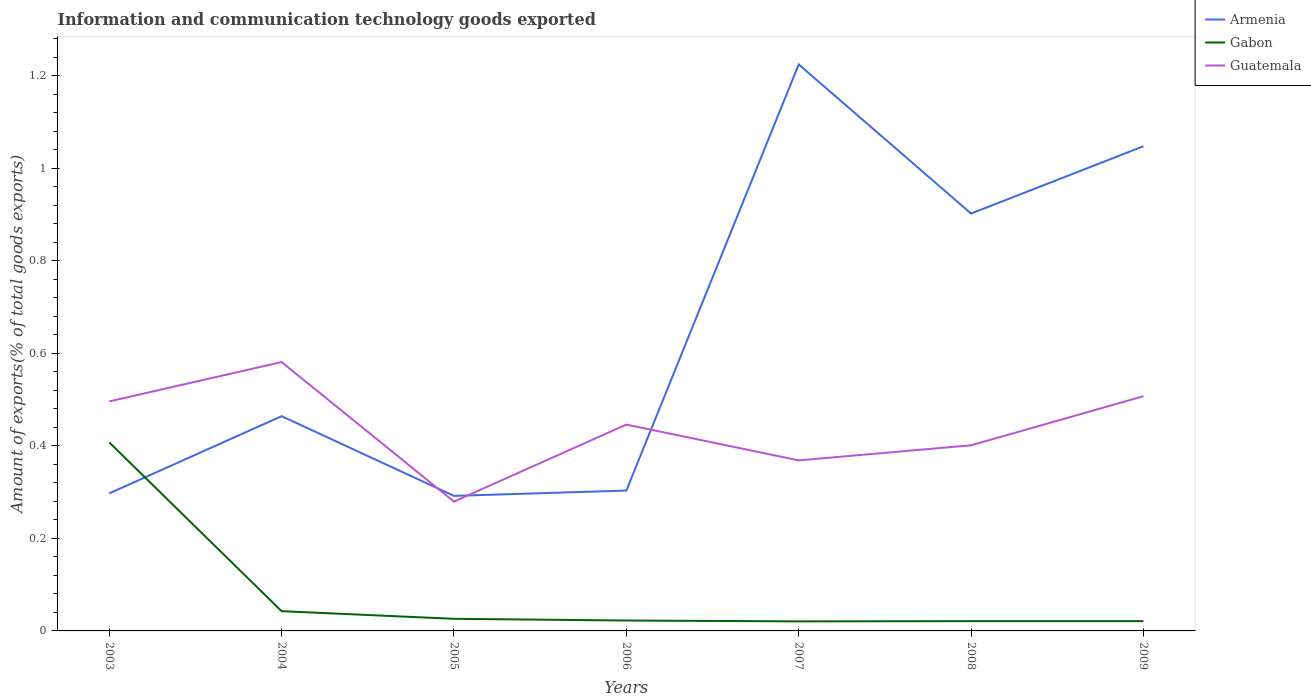How many different coloured lines are there?
Keep it short and to the point. 3. Across all years, what is the maximum amount of goods exported in Armenia?
Provide a succinct answer. 0.29. In which year was the amount of goods exported in Guatemala maximum?
Offer a terse response. 2005. What is the total amount of goods exported in Armenia in the graph?
Keep it short and to the point. -0.92. What is the difference between the highest and the second highest amount of goods exported in Armenia?
Make the answer very short. 0.93. What is the difference between two consecutive major ticks on the Y-axis?
Your response must be concise. 0.2. Are the values on the major ticks of Y-axis written in scientific E-notation?
Give a very brief answer. No. How are the legend labels stacked?
Your answer should be very brief. Vertical. What is the title of the graph?
Provide a succinct answer. Information and communication technology goods exported. Does "Lao PDR" appear as one of the legend labels in the graph?
Your answer should be compact. No. What is the label or title of the X-axis?
Your answer should be compact. Years. What is the label or title of the Y-axis?
Provide a short and direct response. Amount of exports(% of total goods exports). What is the Amount of exports(% of total goods exports) in Armenia in 2003?
Provide a succinct answer. 0.3. What is the Amount of exports(% of total goods exports) in Gabon in 2003?
Provide a short and direct response. 0.41. What is the Amount of exports(% of total goods exports) of Guatemala in 2003?
Make the answer very short. 0.5. What is the Amount of exports(% of total goods exports) of Armenia in 2004?
Make the answer very short. 0.46. What is the Amount of exports(% of total goods exports) of Gabon in 2004?
Keep it short and to the point. 0.04. What is the Amount of exports(% of total goods exports) of Guatemala in 2004?
Offer a very short reply. 0.58. What is the Amount of exports(% of total goods exports) of Armenia in 2005?
Provide a succinct answer. 0.29. What is the Amount of exports(% of total goods exports) of Gabon in 2005?
Ensure brevity in your answer.  0.03. What is the Amount of exports(% of total goods exports) of Guatemala in 2005?
Your answer should be very brief. 0.28. What is the Amount of exports(% of total goods exports) of Armenia in 2006?
Ensure brevity in your answer.  0.3. What is the Amount of exports(% of total goods exports) of Gabon in 2006?
Your answer should be compact. 0.02. What is the Amount of exports(% of total goods exports) of Guatemala in 2006?
Your answer should be compact. 0.45. What is the Amount of exports(% of total goods exports) in Armenia in 2007?
Keep it short and to the point. 1.22. What is the Amount of exports(% of total goods exports) of Gabon in 2007?
Your answer should be very brief. 0.02. What is the Amount of exports(% of total goods exports) in Guatemala in 2007?
Your answer should be compact. 0.37. What is the Amount of exports(% of total goods exports) in Armenia in 2008?
Provide a succinct answer. 0.9. What is the Amount of exports(% of total goods exports) in Gabon in 2008?
Provide a succinct answer. 0.02. What is the Amount of exports(% of total goods exports) of Guatemala in 2008?
Your answer should be very brief. 0.4. What is the Amount of exports(% of total goods exports) of Armenia in 2009?
Make the answer very short. 1.05. What is the Amount of exports(% of total goods exports) in Gabon in 2009?
Offer a terse response. 0.02. What is the Amount of exports(% of total goods exports) in Guatemala in 2009?
Make the answer very short. 0.51. Across all years, what is the maximum Amount of exports(% of total goods exports) in Armenia?
Offer a very short reply. 1.22. Across all years, what is the maximum Amount of exports(% of total goods exports) in Gabon?
Provide a succinct answer. 0.41. Across all years, what is the maximum Amount of exports(% of total goods exports) in Guatemala?
Provide a succinct answer. 0.58. Across all years, what is the minimum Amount of exports(% of total goods exports) of Armenia?
Offer a terse response. 0.29. Across all years, what is the minimum Amount of exports(% of total goods exports) of Gabon?
Your answer should be very brief. 0.02. Across all years, what is the minimum Amount of exports(% of total goods exports) in Guatemala?
Provide a short and direct response. 0.28. What is the total Amount of exports(% of total goods exports) of Armenia in the graph?
Provide a short and direct response. 4.53. What is the total Amount of exports(% of total goods exports) of Gabon in the graph?
Your response must be concise. 0.56. What is the total Amount of exports(% of total goods exports) of Guatemala in the graph?
Ensure brevity in your answer.  3.08. What is the difference between the Amount of exports(% of total goods exports) in Armenia in 2003 and that in 2004?
Offer a very short reply. -0.17. What is the difference between the Amount of exports(% of total goods exports) of Gabon in 2003 and that in 2004?
Your answer should be very brief. 0.36. What is the difference between the Amount of exports(% of total goods exports) of Guatemala in 2003 and that in 2004?
Make the answer very short. -0.08. What is the difference between the Amount of exports(% of total goods exports) of Armenia in 2003 and that in 2005?
Offer a very short reply. 0.01. What is the difference between the Amount of exports(% of total goods exports) in Gabon in 2003 and that in 2005?
Offer a terse response. 0.38. What is the difference between the Amount of exports(% of total goods exports) in Guatemala in 2003 and that in 2005?
Your response must be concise. 0.22. What is the difference between the Amount of exports(% of total goods exports) of Armenia in 2003 and that in 2006?
Your answer should be compact. -0.01. What is the difference between the Amount of exports(% of total goods exports) in Gabon in 2003 and that in 2006?
Offer a terse response. 0.38. What is the difference between the Amount of exports(% of total goods exports) in Guatemala in 2003 and that in 2006?
Provide a succinct answer. 0.05. What is the difference between the Amount of exports(% of total goods exports) in Armenia in 2003 and that in 2007?
Provide a short and direct response. -0.93. What is the difference between the Amount of exports(% of total goods exports) of Gabon in 2003 and that in 2007?
Provide a short and direct response. 0.39. What is the difference between the Amount of exports(% of total goods exports) of Guatemala in 2003 and that in 2007?
Make the answer very short. 0.13. What is the difference between the Amount of exports(% of total goods exports) of Armenia in 2003 and that in 2008?
Give a very brief answer. -0.6. What is the difference between the Amount of exports(% of total goods exports) of Gabon in 2003 and that in 2008?
Offer a terse response. 0.39. What is the difference between the Amount of exports(% of total goods exports) of Guatemala in 2003 and that in 2008?
Your response must be concise. 0.09. What is the difference between the Amount of exports(% of total goods exports) of Armenia in 2003 and that in 2009?
Offer a very short reply. -0.75. What is the difference between the Amount of exports(% of total goods exports) in Gabon in 2003 and that in 2009?
Your answer should be very brief. 0.39. What is the difference between the Amount of exports(% of total goods exports) of Guatemala in 2003 and that in 2009?
Your answer should be compact. -0.01. What is the difference between the Amount of exports(% of total goods exports) in Armenia in 2004 and that in 2005?
Your response must be concise. 0.17. What is the difference between the Amount of exports(% of total goods exports) in Gabon in 2004 and that in 2005?
Your answer should be very brief. 0.02. What is the difference between the Amount of exports(% of total goods exports) of Guatemala in 2004 and that in 2005?
Ensure brevity in your answer.  0.3. What is the difference between the Amount of exports(% of total goods exports) in Armenia in 2004 and that in 2006?
Your answer should be very brief. 0.16. What is the difference between the Amount of exports(% of total goods exports) in Gabon in 2004 and that in 2006?
Ensure brevity in your answer.  0.02. What is the difference between the Amount of exports(% of total goods exports) of Guatemala in 2004 and that in 2006?
Offer a very short reply. 0.14. What is the difference between the Amount of exports(% of total goods exports) of Armenia in 2004 and that in 2007?
Make the answer very short. -0.76. What is the difference between the Amount of exports(% of total goods exports) of Gabon in 2004 and that in 2007?
Provide a succinct answer. 0.02. What is the difference between the Amount of exports(% of total goods exports) of Guatemala in 2004 and that in 2007?
Provide a short and direct response. 0.21. What is the difference between the Amount of exports(% of total goods exports) of Armenia in 2004 and that in 2008?
Provide a short and direct response. -0.44. What is the difference between the Amount of exports(% of total goods exports) of Gabon in 2004 and that in 2008?
Keep it short and to the point. 0.02. What is the difference between the Amount of exports(% of total goods exports) in Guatemala in 2004 and that in 2008?
Make the answer very short. 0.18. What is the difference between the Amount of exports(% of total goods exports) in Armenia in 2004 and that in 2009?
Keep it short and to the point. -0.58. What is the difference between the Amount of exports(% of total goods exports) in Gabon in 2004 and that in 2009?
Keep it short and to the point. 0.02. What is the difference between the Amount of exports(% of total goods exports) of Guatemala in 2004 and that in 2009?
Provide a succinct answer. 0.07. What is the difference between the Amount of exports(% of total goods exports) in Armenia in 2005 and that in 2006?
Make the answer very short. -0.01. What is the difference between the Amount of exports(% of total goods exports) in Gabon in 2005 and that in 2006?
Provide a short and direct response. 0. What is the difference between the Amount of exports(% of total goods exports) of Guatemala in 2005 and that in 2006?
Ensure brevity in your answer.  -0.17. What is the difference between the Amount of exports(% of total goods exports) of Armenia in 2005 and that in 2007?
Your response must be concise. -0.93. What is the difference between the Amount of exports(% of total goods exports) of Gabon in 2005 and that in 2007?
Make the answer very short. 0.01. What is the difference between the Amount of exports(% of total goods exports) in Guatemala in 2005 and that in 2007?
Provide a short and direct response. -0.09. What is the difference between the Amount of exports(% of total goods exports) of Armenia in 2005 and that in 2008?
Provide a succinct answer. -0.61. What is the difference between the Amount of exports(% of total goods exports) of Gabon in 2005 and that in 2008?
Your answer should be very brief. 0.01. What is the difference between the Amount of exports(% of total goods exports) of Guatemala in 2005 and that in 2008?
Keep it short and to the point. -0.12. What is the difference between the Amount of exports(% of total goods exports) of Armenia in 2005 and that in 2009?
Offer a terse response. -0.76. What is the difference between the Amount of exports(% of total goods exports) of Gabon in 2005 and that in 2009?
Provide a succinct answer. 0.01. What is the difference between the Amount of exports(% of total goods exports) of Guatemala in 2005 and that in 2009?
Your answer should be compact. -0.23. What is the difference between the Amount of exports(% of total goods exports) of Armenia in 2006 and that in 2007?
Your answer should be very brief. -0.92. What is the difference between the Amount of exports(% of total goods exports) of Gabon in 2006 and that in 2007?
Make the answer very short. 0. What is the difference between the Amount of exports(% of total goods exports) in Guatemala in 2006 and that in 2007?
Provide a short and direct response. 0.08. What is the difference between the Amount of exports(% of total goods exports) of Armenia in 2006 and that in 2008?
Your response must be concise. -0.6. What is the difference between the Amount of exports(% of total goods exports) in Gabon in 2006 and that in 2008?
Provide a succinct answer. 0. What is the difference between the Amount of exports(% of total goods exports) of Guatemala in 2006 and that in 2008?
Your response must be concise. 0.04. What is the difference between the Amount of exports(% of total goods exports) in Armenia in 2006 and that in 2009?
Keep it short and to the point. -0.74. What is the difference between the Amount of exports(% of total goods exports) of Gabon in 2006 and that in 2009?
Ensure brevity in your answer.  0. What is the difference between the Amount of exports(% of total goods exports) of Guatemala in 2006 and that in 2009?
Give a very brief answer. -0.06. What is the difference between the Amount of exports(% of total goods exports) of Armenia in 2007 and that in 2008?
Your answer should be very brief. 0.32. What is the difference between the Amount of exports(% of total goods exports) of Gabon in 2007 and that in 2008?
Your response must be concise. -0. What is the difference between the Amount of exports(% of total goods exports) in Guatemala in 2007 and that in 2008?
Ensure brevity in your answer.  -0.03. What is the difference between the Amount of exports(% of total goods exports) in Armenia in 2007 and that in 2009?
Your answer should be very brief. 0.18. What is the difference between the Amount of exports(% of total goods exports) in Gabon in 2007 and that in 2009?
Provide a succinct answer. -0. What is the difference between the Amount of exports(% of total goods exports) of Guatemala in 2007 and that in 2009?
Your answer should be very brief. -0.14. What is the difference between the Amount of exports(% of total goods exports) in Armenia in 2008 and that in 2009?
Offer a terse response. -0.15. What is the difference between the Amount of exports(% of total goods exports) of Guatemala in 2008 and that in 2009?
Your answer should be compact. -0.11. What is the difference between the Amount of exports(% of total goods exports) of Armenia in 2003 and the Amount of exports(% of total goods exports) of Gabon in 2004?
Provide a succinct answer. 0.25. What is the difference between the Amount of exports(% of total goods exports) of Armenia in 2003 and the Amount of exports(% of total goods exports) of Guatemala in 2004?
Ensure brevity in your answer.  -0.28. What is the difference between the Amount of exports(% of total goods exports) of Gabon in 2003 and the Amount of exports(% of total goods exports) of Guatemala in 2004?
Offer a terse response. -0.17. What is the difference between the Amount of exports(% of total goods exports) in Armenia in 2003 and the Amount of exports(% of total goods exports) in Gabon in 2005?
Provide a succinct answer. 0.27. What is the difference between the Amount of exports(% of total goods exports) of Armenia in 2003 and the Amount of exports(% of total goods exports) of Guatemala in 2005?
Your answer should be very brief. 0.02. What is the difference between the Amount of exports(% of total goods exports) of Gabon in 2003 and the Amount of exports(% of total goods exports) of Guatemala in 2005?
Provide a short and direct response. 0.13. What is the difference between the Amount of exports(% of total goods exports) of Armenia in 2003 and the Amount of exports(% of total goods exports) of Gabon in 2006?
Your answer should be compact. 0.27. What is the difference between the Amount of exports(% of total goods exports) of Armenia in 2003 and the Amount of exports(% of total goods exports) of Guatemala in 2006?
Give a very brief answer. -0.15. What is the difference between the Amount of exports(% of total goods exports) in Gabon in 2003 and the Amount of exports(% of total goods exports) in Guatemala in 2006?
Provide a short and direct response. -0.04. What is the difference between the Amount of exports(% of total goods exports) of Armenia in 2003 and the Amount of exports(% of total goods exports) of Gabon in 2007?
Your answer should be compact. 0.28. What is the difference between the Amount of exports(% of total goods exports) in Armenia in 2003 and the Amount of exports(% of total goods exports) in Guatemala in 2007?
Offer a terse response. -0.07. What is the difference between the Amount of exports(% of total goods exports) of Gabon in 2003 and the Amount of exports(% of total goods exports) of Guatemala in 2007?
Offer a terse response. 0.04. What is the difference between the Amount of exports(% of total goods exports) of Armenia in 2003 and the Amount of exports(% of total goods exports) of Gabon in 2008?
Provide a short and direct response. 0.28. What is the difference between the Amount of exports(% of total goods exports) of Armenia in 2003 and the Amount of exports(% of total goods exports) of Guatemala in 2008?
Provide a succinct answer. -0.1. What is the difference between the Amount of exports(% of total goods exports) in Gabon in 2003 and the Amount of exports(% of total goods exports) in Guatemala in 2008?
Offer a terse response. 0.01. What is the difference between the Amount of exports(% of total goods exports) of Armenia in 2003 and the Amount of exports(% of total goods exports) of Gabon in 2009?
Your answer should be compact. 0.28. What is the difference between the Amount of exports(% of total goods exports) in Armenia in 2003 and the Amount of exports(% of total goods exports) in Guatemala in 2009?
Your answer should be very brief. -0.21. What is the difference between the Amount of exports(% of total goods exports) in Gabon in 2003 and the Amount of exports(% of total goods exports) in Guatemala in 2009?
Offer a very short reply. -0.1. What is the difference between the Amount of exports(% of total goods exports) in Armenia in 2004 and the Amount of exports(% of total goods exports) in Gabon in 2005?
Keep it short and to the point. 0.44. What is the difference between the Amount of exports(% of total goods exports) of Armenia in 2004 and the Amount of exports(% of total goods exports) of Guatemala in 2005?
Your response must be concise. 0.18. What is the difference between the Amount of exports(% of total goods exports) of Gabon in 2004 and the Amount of exports(% of total goods exports) of Guatemala in 2005?
Provide a succinct answer. -0.24. What is the difference between the Amount of exports(% of total goods exports) in Armenia in 2004 and the Amount of exports(% of total goods exports) in Gabon in 2006?
Keep it short and to the point. 0.44. What is the difference between the Amount of exports(% of total goods exports) in Armenia in 2004 and the Amount of exports(% of total goods exports) in Guatemala in 2006?
Ensure brevity in your answer.  0.02. What is the difference between the Amount of exports(% of total goods exports) of Gabon in 2004 and the Amount of exports(% of total goods exports) of Guatemala in 2006?
Ensure brevity in your answer.  -0.4. What is the difference between the Amount of exports(% of total goods exports) of Armenia in 2004 and the Amount of exports(% of total goods exports) of Gabon in 2007?
Your answer should be very brief. 0.44. What is the difference between the Amount of exports(% of total goods exports) of Armenia in 2004 and the Amount of exports(% of total goods exports) of Guatemala in 2007?
Offer a terse response. 0.1. What is the difference between the Amount of exports(% of total goods exports) in Gabon in 2004 and the Amount of exports(% of total goods exports) in Guatemala in 2007?
Offer a very short reply. -0.33. What is the difference between the Amount of exports(% of total goods exports) of Armenia in 2004 and the Amount of exports(% of total goods exports) of Gabon in 2008?
Keep it short and to the point. 0.44. What is the difference between the Amount of exports(% of total goods exports) in Armenia in 2004 and the Amount of exports(% of total goods exports) in Guatemala in 2008?
Your answer should be very brief. 0.06. What is the difference between the Amount of exports(% of total goods exports) in Gabon in 2004 and the Amount of exports(% of total goods exports) in Guatemala in 2008?
Provide a succinct answer. -0.36. What is the difference between the Amount of exports(% of total goods exports) in Armenia in 2004 and the Amount of exports(% of total goods exports) in Gabon in 2009?
Provide a succinct answer. 0.44. What is the difference between the Amount of exports(% of total goods exports) of Armenia in 2004 and the Amount of exports(% of total goods exports) of Guatemala in 2009?
Offer a terse response. -0.04. What is the difference between the Amount of exports(% of total goods exports) of Gabon in 2004 and the Amount of exports(% of total goods exports) of Guatemala in 2009?
Keep it short and to the point. -0.46. What is the difference between the Amount of exports(% of total goods exports) of Armenia in 2005 and the Amount of exports(% of total goods exports) of Gabon in 2006?
Offer a terse response. 0.27. What is the difference between the Amount of exports(% of total goods exports) in Armenia in 2005 and the Amount of exports(% of total goods exports) in Guatemala in 2006?
Provide a succinct answer. -0.15. What is the difference between the Amount of exports(% of total goods exports) of Gabon in 2005 and the Amount of exports(% of total goods exports) of Guatemala in 2006?
Keep it short and to the point. -0.42. What is the difference between the Amount of exports(% of total goods exports) of Armenia in 2005 and the Amount of exports(% of total goods exports) of Gabon in 2007?
Offer a very short reply. 0.27. What is the difference between the Amount of exports(% of total goods exports) of Armenia in 2005 and the Amount of exports(% of total goods exports) of Guatemala in 2007?
Offer a very short reply. -0.08. What is the difference between the Amount of exports(% of total goods exports) of Gabon in 2005 and the Amount of exports(% of total goods exports) of Guatemala in 2007?
Provide a succinct answer. -0.34. What is the difference between the Amount of exports(% of total goods exports) in Armenia in 2005 and the Amount of exports(% of total goods exports) in Gabon in 2008?
Offer a very short reply. 0.27. What is the difference between the Amount of exports(% of total goods exports) in Armenia in 2005 and the Amount of exports(% of total goods exports) in Guatemala in 2008?
Offer a terse response. -0.11. What is the difference between the Amount of exports(% of total goods exports) in Gabon in 2005 and the Amount of exports(% of total goods exports) in Guatemala in 2008?
Provide a succinct answer. -0.37. What is the difference between the Amount of exports(% of total goods exports) in Armenia in 2005 and the Amount of exports(% of total goods exports) in Gabon in 2009?
Provide a short and direct response. 0.27. What is the difference between the Amount of exports(% of total goods exports) of Armenia in 2005 and the Amount of exports(% of total goods exports) of Guatemala in 2009?
Offer a terse response. -0.22. What is the difference between the Amount of exports(% of total goods exports) of Gabon in 2005 and the Amount of exports(% of total goods exports) of Guatemala in 2009?
Your answer should be very brief. -0.48. What is the difference between the Amount of exports(% of total goods exports) of Armenia in 2006 and the Amount of exports(% of total goods exports) of Gabon in 2007?
Keep it short and to the point. 0.28. What is the difference between the Amount of exports(% of total goods exports) of Armenia in 2006 and the Amount of exports(% of total goods exports) of Guatemala in 2007?
Your response must be concise. -0.07. What is the difference between the Amount of exports(% of total goods exports) in Gabon in 2006 and the Amount of exports(% of total goods exports) in Guatemala in 2007?
Offer a very short reply. -0.35. What is the difference between the Amount of exports(% of total goods exports) of Armenia in 2006 and the Amount of exports(% of total goods exports) of Gabon in 2008?
Provide a succinct answer. 0.28. What is the difference between the Amount of exports(% of total goods exports) of Armenia in 2006 and the Amount of exports(% of total goods exports) of Guatemala in 2008?
Your answer should be very brief. -0.1. What is the difference between the Amount of exports(% of total goods exports) in Gabon in 2006 and the Amount of exports(% of total goods exports) in Guatemala in 2008?
Ensure brevity in your answer.  -0.38. What is the difference between the Amount of exports(% of total goods exports) of Armenia in 2006 and the Amount of exports(% of total goods exports) of Gabon in 2009?
Make the answer very short. 0.28. What is the difference between the Amount of exports(% of total goods exports) in Armenia in 2006 and the Amount of exports(% of total goods exports) in Guatemala in 2009?
Provide a short and direct response. -0.2. What is the difference between the Amount of exports(% of total goods exports) of Gabon in 2006 and the Amount of exports(% of total goods exports) of Guatemala in 2009?
Give a very brief answer. -0.48. What is the difference between the Amount of exports(% of total goods exports) of Armenia in 2007 and the Amount of exports(% of total goods exports) of Gabon in 2008?
Your answer should be very brief. 1.2. What is the difference between the Amount of exports(% of total goods exports) of Armenia in 2007 and the Amount of exports(% of total goods exports) of Guatemala in 2008?
Provide a short and direct response. 0.82. What is the difference between the Amount of exports(% of total goods exports) in Gabon in 2007 and the Amount of exports(% of total goods exports) in Guatemala in 2008?
Make the answer very short. -0.38. What is the difference between the Amount of exports(% of total goods exports) of Armenia in 2007 and the Amount of exports(% of total goods exports) of Gabon in 2009?
Offer a terse response. 1.2. What is the difference between the Amount of exports(% of total goods exports) of Armenia in 2007 and the Amount of exports(% of total goods exports) of Guatemala in 2009?
Your response must be concise. 0.72. What is the difference between the Amount of exports(% of total goods exports) of Gabon in 2007 and the Amount of exports(% of total goods exports) of Guatemala in 2009?
Make the answer very short. -0.49. What is the difference between the Amount of exports(% of total goods exports) of Armenia in 2008 and the Amount of exports(% of total goods exports) of Gabon in 2009?
Give a very brief answer. 0.88. What is the difference between the Amount of exports(% of total goods exports) in Armenia in 2008 and the Amount of exports(% of total goods exports) in Guatemala in 2009?
Provide a succinct answer. 0.39. What is the difference between the Amount of exports(% of total goods exports) of Gabon in 2008 and the Amount of exports(% of total goods exports) of Guatemala in 2009?
Make the answer very short. -0.49. What is the average Amount of exports(% of total goods exports) in Armenia per year?
Make the answer very short. 0.65. What is the average Amount of exports(% of total goods exports) of Gabon per year?
Keep it short and to the point. 0.08. What is the average Amount of exports(% of total goods exports) in Guatemala per year?
Make the answer very short. 0.44. In the year 2003, what is the difference between the Amount of exports(% of total goods exports) in Armenia and Amount of exports(% of total goods exports) in Gabon?
Ensure brevity in your answer.  -0.11. In the year 2003, what is the difference between the Amount of exports(% of total goods exports) of Armenia and Amount of exports(% of total goods exports) of Guatemala?
Provide a short and direct response. -0.2. In the year 2003, what is the difference between the Amount of exports(% of total goods exports) in Gabon and Amount of exports(% of total goods exports) in Guatemala?
Your response must be concise. -0.09. In the year 2004, what is the difference between the Amount of exports(% of total goods exports) of Armenia and Amount of exports(% of total goods exports) of Gabon?
Keep it short and to the point. 0.42. In the year 2004, what is the difference between the Amount of exports(% of total goods exports) of Armenia and Amount of exports(% of total goods exports) of Guatemala?
Ensure brevity in your answer.  -0.12. In the year 2004, what is the difference between the Amount of exports(% of total goods exports) of Gabon and Amount of exports(% of total goods exports) of Guatemala?
Your response must be concise. -0.54. In the year 2005, what is the difference between the Amount of exports(% of total goods exports) in Armenia and Amount of exports(% of total goods exports) in Gabon?
Offer a terse response. 0.27. In the year 2005, what is the difference between the Amount of exports(% of total goods exports) in Armenia and Amount of exports(% of total goods exports) in Guatemala?
Your response must be concise. 0.01. In the year 2005, what is the difference between the Amount of exports(% of total goods exports) of Gabon and Amount of exports(% of total goods exports) of Guatemala?
Make the answer very short. -0.25. In the year 2006, what is the difference between the Amount of exports(% of total goods exports) of Armenia and Amount of exports(% of total goods exports) of Gabon?
Keep it short and to the point. 0.28. In the year 2006, what is the difference between the Amount of exports(% of total goods exports) in Armenia and Amount of exports(% of total goods exports) in Guatemala?
Ensure brevity in your answer.  -0.14. In the year 2006, what is the difference between the Amount of exports(% of total goods exports) of Gabon and Amount of exports(% of total goods exports) of Guatemala?
Offer a very short reply. -0.42. In the year 2007, what is the difference between the Amount of exports(% of total goods exports) of Armenia and Amount of exports(% of total goods exports) of Gabon?
Ensure brevity in your answer.  1.2. In the year 2007, what is the difference between the Amount of exports(% of total goods exports) of Armenia and Amount of exports(% of total goods exports) of Guatemala?
Your answer should be very brief. 0.86. In the year 2007, what is the difference between the Amount of exports(% of total goods exports) in Gabon and Amount of exports(% of total goods exports) in Guatemala?
Give a very brief answer. -0.35. In the year 2008, what is the difference between the Amount of exports(% of total goods exports) in Armenia and Amount of exports(% of total goods exports) in Gabon?
Offer a very short reply. 0.88. In the year 2008, what is the difference between the Amount of exports(% of total goods exports) in Armenia and Amount of exports(% of total goods exports) in Guatemala?
Your response must be concise. 0.5. In the year 2008, what is the difference between the Amount of exports(% of total goods exports) of Gabon and Amount of exports(% of total goods exports) of Guatemala?
Make the answer very short. -0.38. In the year 2009, what is the difference between the Amount of exports(% of total goods exports) in Armenia and Amount of exports(% of total goods exports) in Gabon?
Make the answer very short. 1.03. In the year 2009, what is the difference between the Amount of exports(% of total goods exports) of Armenia and Amount of exports(% of total goods exports) of Guatemala?
Your answer should be compact. 0.54. In the year 2009, what is the difference between the Amount of exports(% of total goods exports) of Gabon and Amount of exports(% of total goods exports) of Guatemala?
Your response must be concise. -0.49. What is the ratio of the Amount of exports(% of total goods exports) of Armenia in 2003 to that in 2004?
Your response must be concise. 0.64. What is the ratio of the Amount of exports(% of total goods exports) in Gabon in 2003 to that in 2004?
Provide a succinct answer. 9.55. What is the ratio of the Amount of exports(% of total goods exports) in Guatemala in 2003 to that in 2004?
Make the answer very short. 0.85. What is the ratio of the Amount of exports(% of total goods exports) in Armenia in 2003 to that in 2005?
Offer a very short reply. 1.02. What is the ratio of the Amount of exports(% of total goods exports) of Gabon in 2003 to that in 2005?
Your response must be concise. 15.56. What is the ratio of the Amount of exports(% of total goods exports) in Guatemala in 2003 to that in 2005?
Your answer should be very brief. 1.77. What is the ratio of the Amount of exports(% of total goods exports) of Armenia in 2003 to that in 2006?
Ensure brevity in your answer.  0.98. What is the ratio of the Amount of exports(% of total goods exports) in Gabon in 2003 to that in 2006?
Make the answer very short. 18.12. What is the ratio of the Amount of exports(% of total goods exports) of Guatemala in 2003 to that in 2006?
Ensure brevity in your answer.  1.11. What is the ratio of the Amount of exports(% of total goods exports) in Armenia in 2003 to that in 2007?
Offer a terse response. 0.24. What is the ratio of the Amount of exports(% of total goods exports) in Gabon in 2003 to that in 2007?
Your answer should be very brief. 19.75. What is the ratio of the Amount of exports(% of total goods exports) of Guatemala in 2003 to that in 2007?
Ensure brevity in your answer.  1.35. What is the ratio of the Amount of exports(% of total goods exports) in Armenia in 2003 to that in 2008?
Offer a very short reply. 0.33. What is the ratio of the Amount of exports(% of total goods exports) of Gabon in 2003 to that in 2008?
Keep it short and to the point. 19.29. What is the ratio of the Amount of exports(% of total goods exports) in Guatemala in 2003 to that in 2008?
Keep it short and to the point. 1.24. What is the ratio of the Amount of exports(% of total goods exports) of Armenia in 2003 to that in 2009?
Make the answer very short. 0.28. What is the ratio of the Amount of exports(% of total goods exports) in Gabon in 2003 to that in 2009?
Keep it short and to the point. 19.29. What is the ratio of the Amount of exports(% of total goods exports) in Guatemala in 2003 to that in 2009?
Give a very brief answer. 0.98. What is the ratio of the Amount of exports(% of total goods exports) in Armenia in 2004 to that in 2005?
Make the answer very short. 1.59. What is the ratio of the Amount of exports(% of total goods exports) in Gabon in 2004 to that in 2005?
Make the answer very short. 1.63. What is the ratio of the Amount of exports(% of total goods exports) of Guatemala in 2004 to that in 2005?
Offer a very short reply. 2.08. What is the ratio of the Amount of exports(% of total goods exports) in Armenia in 2004 to that in 2006?
Provide a succinct answer. 1.53. What is the ratio of the Amount of exports(% of total goods exports) in Gabon in 2004 to that in 2006?
Your response must be concise. 1.9. What is the ratio of the Amount of exports(% of total goods exports) of Guatemala in 2004 to that in 2006?
Provide a succinct answer. 1.3. What is the ratio of the Amount of exports(% of total goods exports) in Armenia in 2004 to that in 2007?
Ensure brevity in your answer.  0.38. What is the ratio of the Amount of exports(% of total goods exports) in Gabon in 2004 to that in 2007?
Offer a terse response. 2.07. What is the ratio of the Amount of exports(% of total goods exports) in Guatemala in 2004 to that in 2007?
Give a very brief answer. 1.58. What is the ratio of the Amount of exports(% of total goods exports) of Armenia in 2004 to that in 2008?
Your response must be concise. 0.51. What is the ratio of the Amount of exports(% of total goods exports) of Gabon in 2004 to that in 2008?
Give a very brief answer. 2.02. What is the ratio of the Amount of exports(% of total goods exports) in Guatemala in 2004 to that in 2008?
Ensure brevity in your answer.  1.45. What is the ratio of the Amount of exports(% of total goods exports) in Armenia in 2004 to that in 2009?
Your answer should be compact. 0.44. What is the ratio of the Amount of exports(% of total goods exports) of Gabon in 2004 to that in 2009?
Make the answer very short. 2.02. What is the ratio of the Amount of exports(% of total goods exports) of Guatemala in 2004 to that in 2009?
Your answer should be compact. 1.15. What is the ratio of the Amount of exports(% of total goods exports) in Armenia in 2005 to that in 2006?
Your answer should be compact. 0.96. What is the ratio of the Amount of exports(% of total goods exports) in Gabon in 2005 to that in 2006?
Your answer should be very brief. 1.16. What is the ratio of the Amount of exports(% of total goods exports) of Guatemala in 2005 to that in 2006?
Your response must be concise. 0.63. What is the ratio of the Amount of exports(% of total goods exports) of Armenia in 2005 to that in 2007?
Give a very brief answer. 0.24. What is the ratio of the Amount of exports(% of total goods exports) of Gabon in 2005 to that in 2007?
Provide a succinct answer. 1.27. What is the ratio of the Amount of exports(% of total goods exports) in Guatemala in 2005 to that in 2007?
Ensure brevity in your answer.  0.76. What is the ratio of the Amount of exports(% of total goods exports) of Armenia in 2005 to that in 2008?
Your response must be concise. 0.32. What is the ratio of the Amount of exports(% of total goods exports) in Gabon in 2005 to that in 2008?
Offer a terse response. 1.24. What is the ratio of the Amount of exports(% of total goods exports) of Guatemala in 2005 to that in 2008?
Keep it short and to the point. 0.7. What is the ratio of the Amount of exports(% of total goods exports) of Armenia in 2005 to that in 2009?
Offer a terse response. 0.28. What is the ratio of the Amount of exports(% of total goods exports) of Gabon in 2005 to that in 2009?
Your answer should be compact. 1.24. What is the ratio of the Amount of exports(% of total goods exports) of Guatemala in 2005 to that in 2009?
Offer a very short reply. 0.55. What is the ratio of the Amount of exports(% of total goods exports) in Armenia in 2006 to that in 2007?
Offer a terse response. 0.25. What is the ratio of the Amount of exports(% of total goods exports) of Gabon in 2006 to that in 2007?
Keep it short and to the point. 1.09. What is the ratio of the Amount of exports(% of total goods exports) of Guatemala in 2006 to that in 2007?
Give a very brief answer. 1.21. What is the ratio of the Amount of exports(% of total goods exports) of Armenia in 2006 to that in 2008?
Your response must be concise. 0.34. What is the ratio of the Amount of exports(% of total goods exports) in Gabon in 2006 to that in 2008?
Ensure brevity in your answer.  1.06. What is the ratio of the Amount of exports(% of total goods exports) in Guatemala in 2006 to that in 2008?
Your response must be concise. 1.11. What is the ratio of the Amount of exports(% of total goods exports) of Armenia in 2006 to that in 2009?
Offer a very short reply. 0.29. What is the ratio of the Amount of exports(% of total goods exports) in Gabon in 2006 to that in 2009?
Ensure brevity in your answer.  1.06. What is the ratio of the Amount of exports(% of total goods exports) in Guatemala in 2006 to that in 2009?
Your answer should be very brief. 0.88. What is the ratio of the Amount of exports(% of total goods exports) of Armenia in 2007 to that in 2008?
Ensure brevity in your answer.  1.36. What is the ratio of the Amount of exports(% of total goods exports) of Gabon in 2007 to that in 2008?
Ensure brevity in your answer.  0.98. What is the ratio of the Amount of exports(% of total goods exports) in Guatemala in 2007 to that in 2008?
Your response must be concise. 0.92. What is the ratio of the Amount of exports(% of total goods exports) in Armenia in 2007 to that in 2009?
Offer a terse response. 1.17. What is the ratio of the Amount of exports(% of total goods exports) in Gabon in 2007 to that in 2009?
Ensure brevity in your answer.  0.98. What is the ratio of the Amount of exports(% of total goods exports) in Guatemala in 2007 to that in 2009?
Your answer should be very brief. 0.73. What is the ratio of the Amount of exports(% of total goods exports) of Armenia in 2008 to that in 2009?
Make the answer very short. 0.86. What is the ratio of the Amount of exports(% of total goods exports) of Gabon in 2008 to that in 2009?
Your answer should be compact. 1. What is the ratio of the Amount of exports(% of total goods exports) in Guatemala in 2008 to that in 2009?
Your answer should be compact. 0.79. What is the difference between the highest and the second highest Amount of exports(% of total goods exports) in Armenia?
Offer a terse response. 0.18. What is the difference between the highest and the second highest Amount of exports(% of total goods exports) of Gabon?
Offer a very short reply. 0.36. What is the difference between the highest and the second highest Amount of exports(% of total goods exports) of Guatemala?
Your response must be concise. 0.07. What is the difference between the highest and the lowest Amount of exports(% of total goods exports) in Armenia?
Offer a very short reply. 0.93. What is the difference between the highest and the lowest Amount of exports(% of total goods exports) in Gabon?
Your response must be concise. 0.39. What is the difference between the highest and the lowest Amount of exports(% of total goods exports) of Guatemala?
Keep it short and to the point. 0.3. 